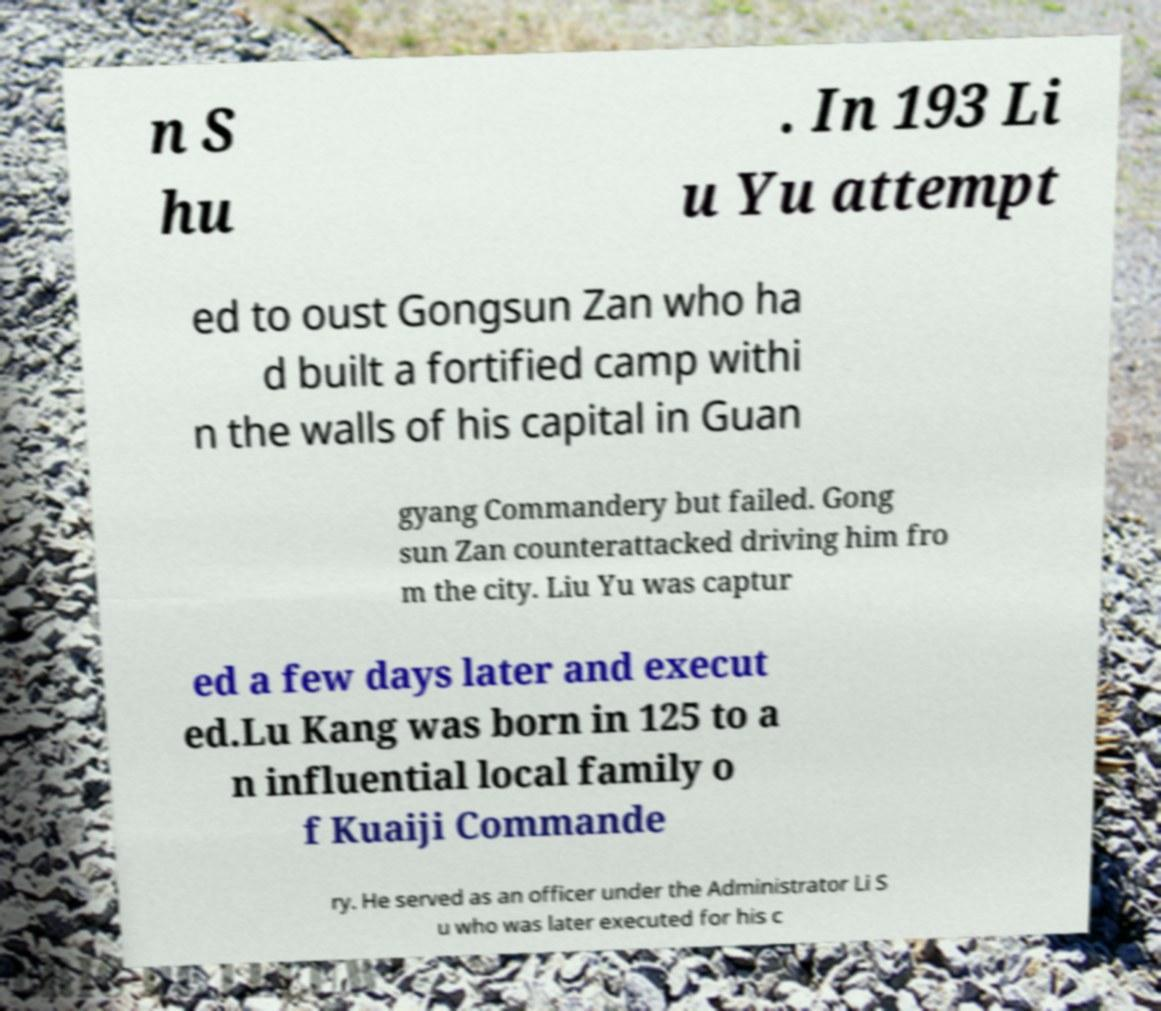What messages or text are displayed in this image? I need them in a readable, typed format. n S hu . In 193 Li u Yu attempt ed to oust Gongsun Zan who ha d built a fortified camp withi n the walls of his capital in Guan gyang Commandery but failed. Gong sun Zan counterattacked driving him fro m the city. Liu Yu was captur ed a few days later and execut ed.Lu Kang was born in 125 to a n influential local family o f Kuaiji Commande ry. He served as an officer under the Administrator Li S u who was later executed for his c 